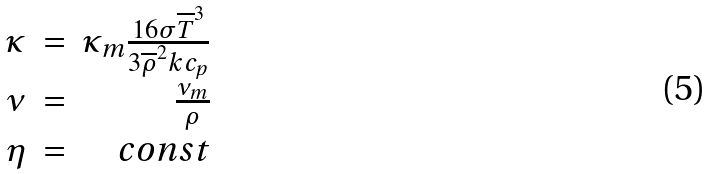<formula> <loc_0><loc_0><loc_500><loc_500>\begin{array} { r r r } \kappa & = & \kappa _ { m } \frac { 1 6 \sigma \overline { T } ^ { 3 } } { 3 \overline { \rho } ^ { 2 } k c _ { p } } \\ \nu & = & \frac { \nu _ { m } } { \rho } \\ \eta & = & c o n s t \\ \end{array}</formula> 